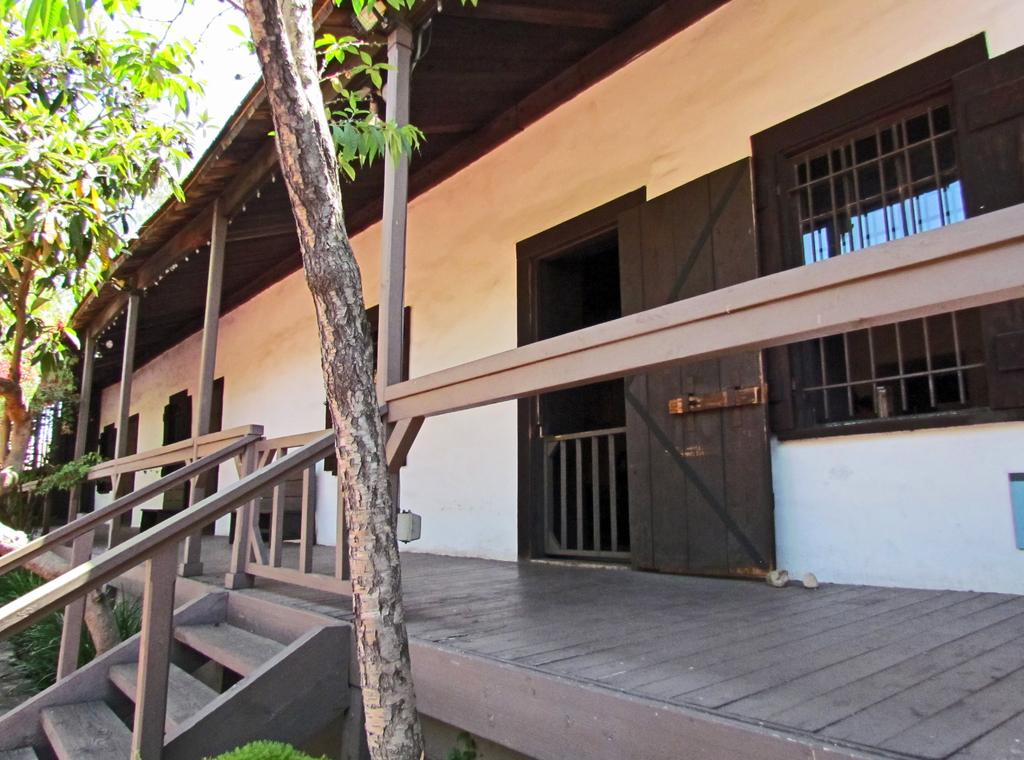What type of structure is present in the image? There is a building in the image. What features can be seen on the building? The building has doors and windows. What architectural element is present in the image? There are wooden stairs in the image. What type of vegetation is visible in the image? Trees with branches and leaves are visible in the image. What other wooden structures can be seen in the image? There are wooden pillars in the image. What time of day is it in the image, and what type of pickle is on the form? The time of day and the presence of a pickle or form cannot be determined from the image, as it only features a building, wooden stairs, trees, and wooden pillars. 